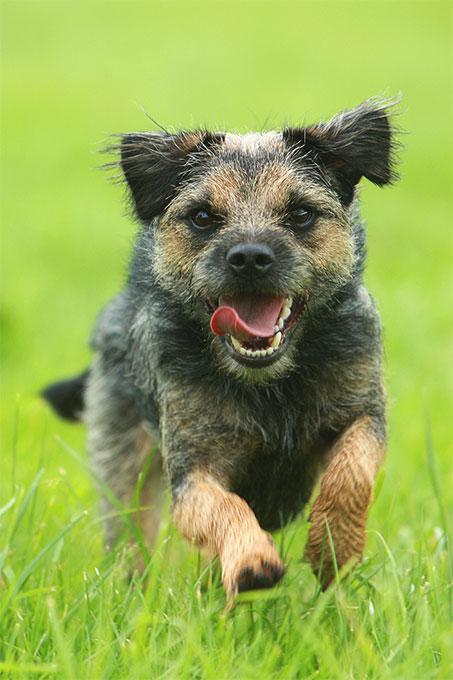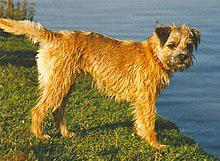The first image is the image on the left, the second image is the image on the right. Evaluate the accuracy of this statement regarding the images: "There are no more than four dogs". Is it true? Answer yes or no. Yes. 